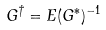<formula> <loc_0><loc_0><loc_500><loc_500>G ^ { \dagger } = E ( G ^ { * } ) ^ { - 1 }</formula> 